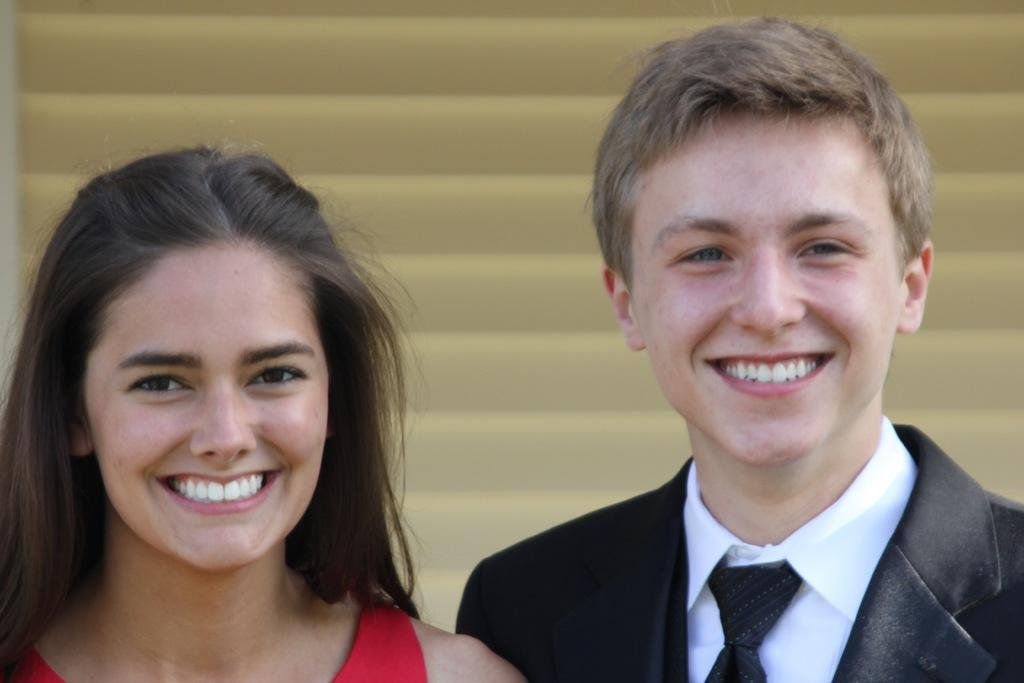What is the expression on the man's face in the image? The man is smiling in the image. What is the expression on the woman's face in the image? The woman is also smiling in the image. What can be seen in the background of the image? There is a window shutter in the background of the image. What type of drain is visible in the image? There is no drain present in the image. What is the value of the goose in the image? There is no goose present in the image, so it is not possible to determine its value. 